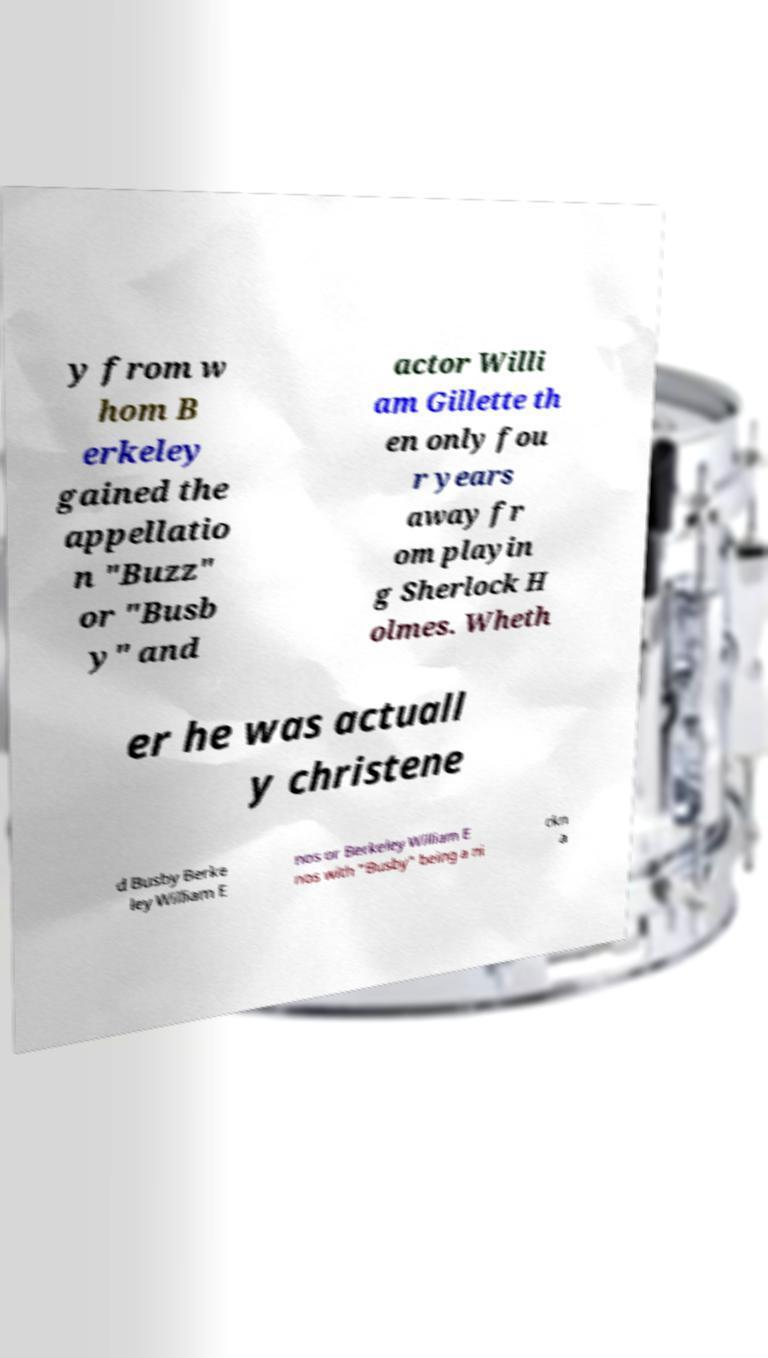For documentation purposes, I need the text within this image transcribed. Could you provide that? y from w hom B erkeley gained the appellatio n "Buzz" or "Busb y" and actor Willi am Gillette th en only fou r years away fr om playin g Sherlock H olmes. Wheth er he was actuall y christene d Busby Berke ley William E nos or Berkeley William E nos with "Busby" being a ni ckn a 